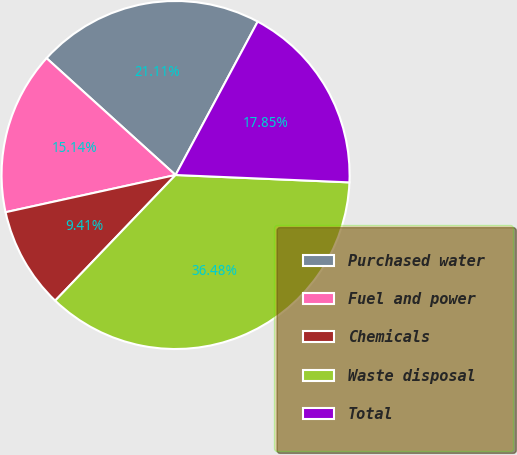<chart> <loc_0><loc_0><loc_500><loc_500><pie_chart><fcel>Purchased water<fcel>Fuel and power<fcel>Chemicals<fcel>Waste disposal<fcel>Total<nl><fcel>21.11%<fcel>15.14%<fcel>9.41%<fcel>36.48%<fcel>17.85%<nl></chart> 